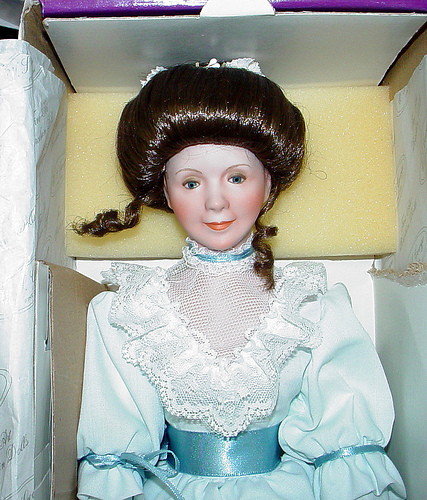<image>
Is the doll in front of the box? No. The doll is not in front of the box. The spatial positioning shows a different relationship between these objects. 